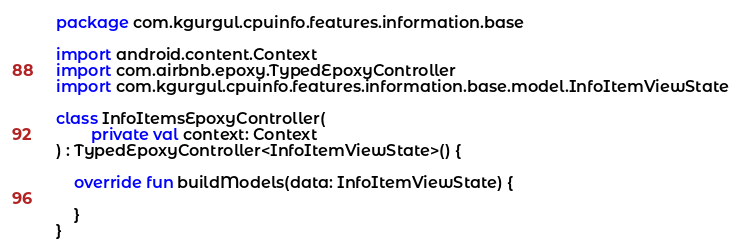<code> <loc_0><loc_0><loc_500><loc_500><_Kotlin_>package com.kgurgul.cpuinfo.features.information.base

import android.content.Context
import com.airbnb.epoxy.TypedEpoxyController
import com.kgurgul.cpuinfo.features.information.base.model.InfoItemViewState

class InfoItemsEpoxyController(
        private val context: Context
) : TypedEpoxyController<InfoItemViewState>() {

    override fun buildModels(data: InfoItemViewState) {

    }
}</code> 